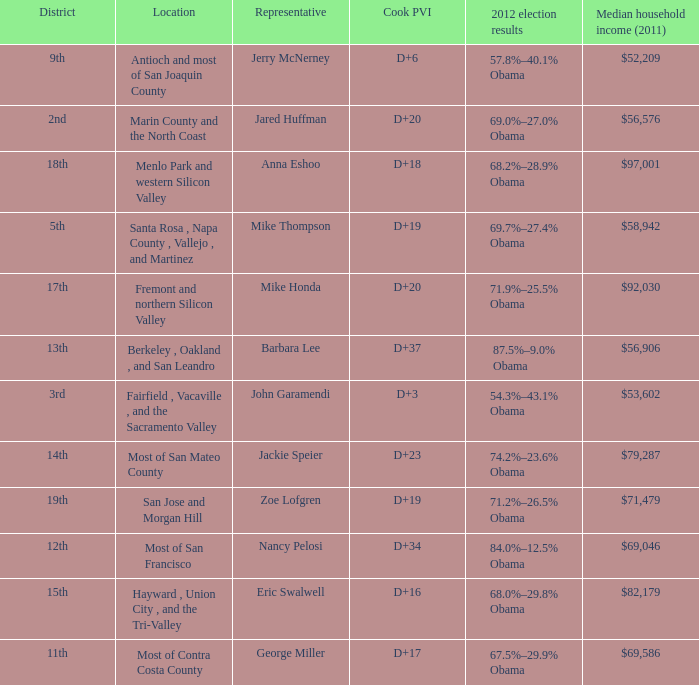How many election results in 2012 had a Cook PVI of D+16? 1.0. 